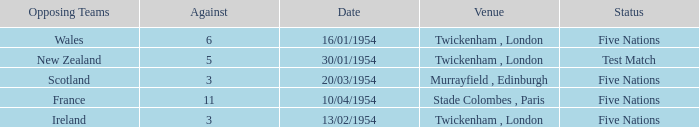What is the lowest against for games played in the stade colombes, paris venue? 11.0. 